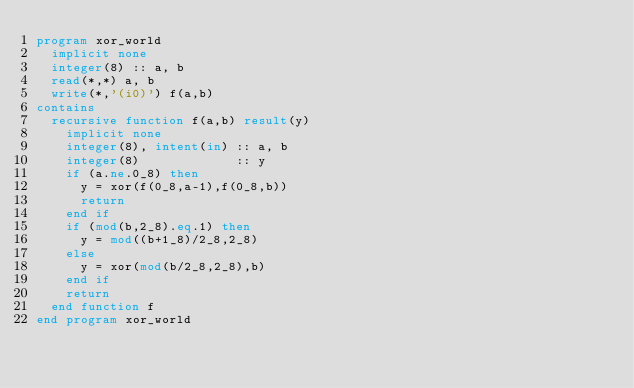<code> <loc_0><loc_0><loc_500><loc_500><_FORTRAN_>program xor_world
  implicit none
  integer(8) :: a, b
  read(*,*) a, b
  write(*,'(i0)') f(a,b)
contains
  recursive function f(a,b) result(y)
    implicit none
    integer(8), intent(in) :: a, b
    integer(8)             :: y
    if (a.ne.0_8) then
      y = xor(f(0_8,a-1),f(0_8,b))
      return
    end if
    if (mod(b,2_8).eq.1) then
      y = mod((b+1_8)/2_8,2_8)
    else
      y = xor(mod(b/2_8,2_8),b)
    end if
    return
  end function f
end program xor_world</code> 